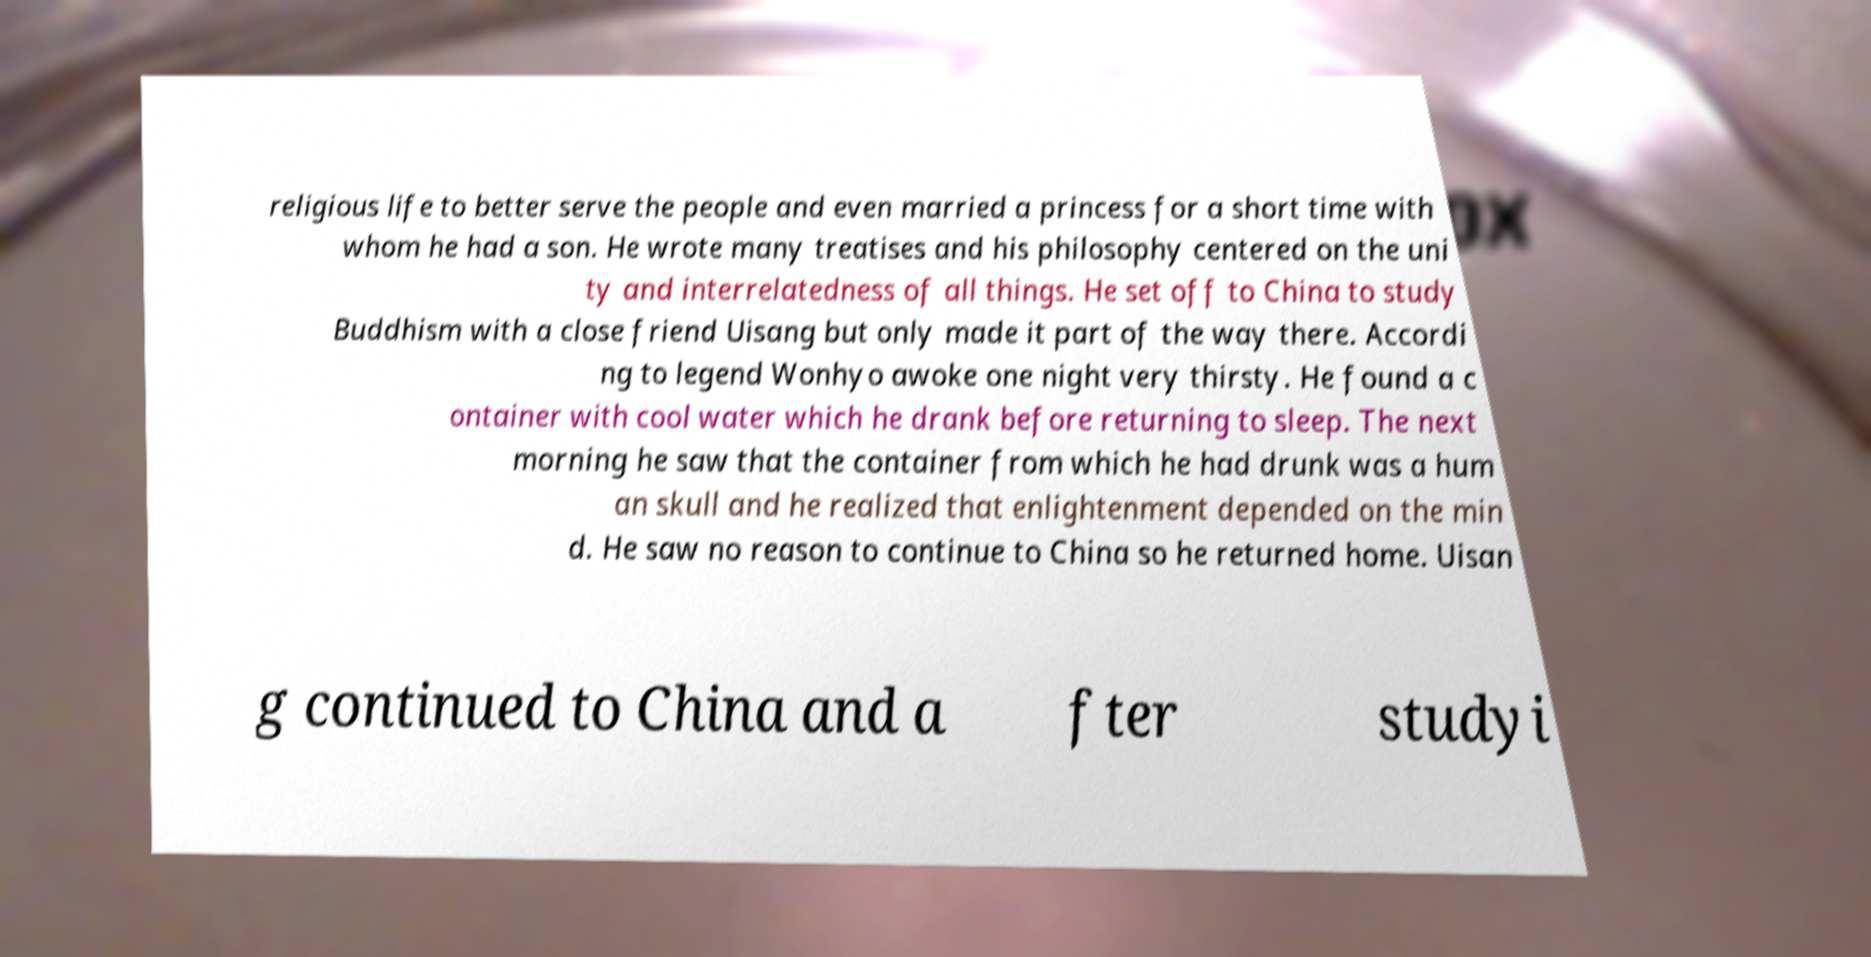Could you assist in decoding the text presented in this image and type it out clearly? religious life to better serve the people and even married a princess for a short time with whom he had a son. He wrote many treatises and his philosophy centered on the uni ty and interrelatedness of all things. He set off to China to study Buddhism with a close friend Uisang but only made it part of the way there. Accordi ng to legend Wonhyo awoke one night very thirsty. He found a c ontainer with cool water which he drank before returning to sleep. The next morning he saw that the container from which he had drunk was a hum an skull and he realized that enlightenment depended on the min d. He saw no reason to continue to China so he returned home. Uisan g continued to China and a fter studyi 